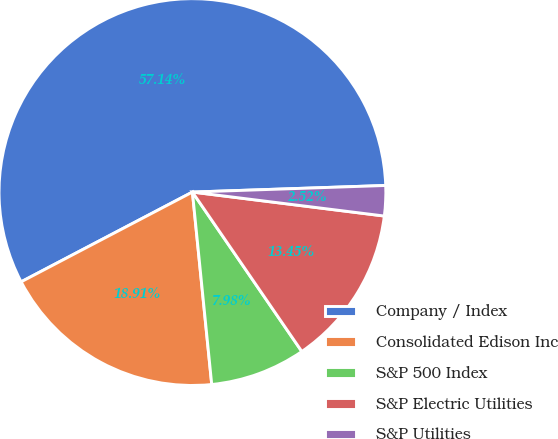<chart> <loc_0><loc_0><loc_500><loc_500><pie_chart><fcel>Company / Index<fcel>Consolidated Edison Inc<fcel>S&P 500 Index<fcel>S&P Electric Utilities<fcel>S&P Utilities<nl><fcel>57.14%<fcel>18.91%<fcel>7.98%<fcel>13.45%<fcel>2.52%<nl></chart> 